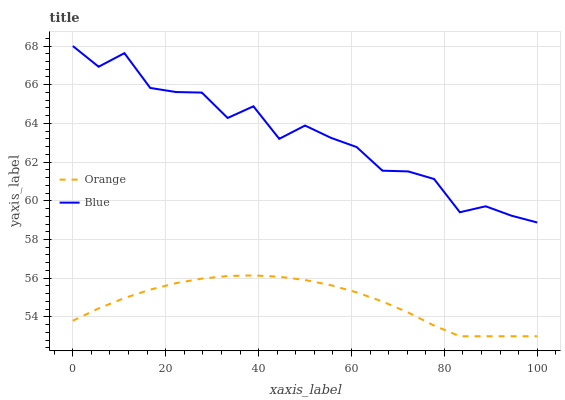Does Orange have the minimum area under the curve?
Answer yes or no. Yes. Does Blue have the maximum area under the curve?
Answer yes or no. Yes. Does Blue have the minimum area under the curve?
Answer yes or no. No. Is Orange the smoothest?
Answer yes or no. Yes. Is Blue the roughest?
Answer yes or no. Yes. Is Blue the smoothest?
Answer yes or no. No. Does Blue have the lowest value?
Answer yes or no. No. Does Blue have the highest value?
Answer yes or no. Yes. Is Orange less than Blue?
Answer yes or no. Yes. Is Blue greater than Orange?
Answer yes or no. Yes. Does Orange intersect Blue?
Answer yes or no. No. 